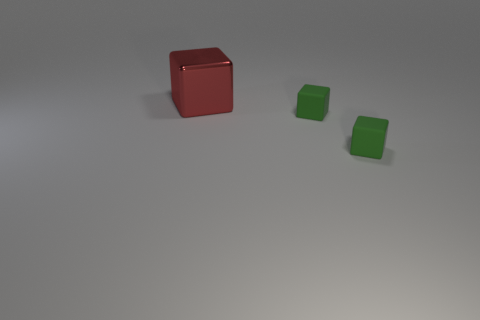Subtract all metallic blocks. How many blocks are left? 2 Subtract all green blocks. How many blocks are left? 1 Subtract 3 blocks. How many blocks are left? 0 Add 3 tiny green objects. How many objects exist? 6 Subtract all gray cylinders. How many red blocks are left? 1 Add 2 green blocks. How many green blocks are left? 4 Add 2 red things. How many red things exist? 3 Subtract 0 yellow blocks. How many objects are left? 3 Subtract all purple cubes. Subtract all yellow cylinders. How many cubes are left? 3 Subtract all small rubber cubes. Subtract all large red things. How many objects are left? 0 